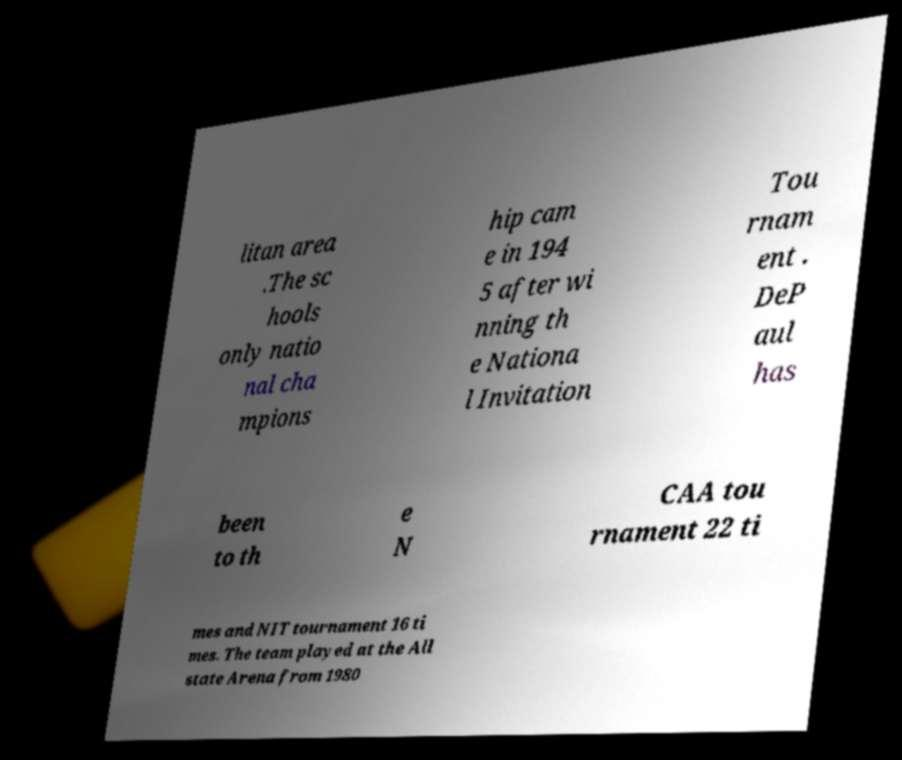I need the written content from this picture converted into text. Can you do that? litan area .The sc hools only natio nal cha mpions hip cam e in 194 5 after wi nning th e Nationa l Invitation Tou rnam ent . DeP aul has been to th e N CAA tou rnament 22 ti mes and NIT tournament 16 ti mes. The team played at the All state Arena from 1980 